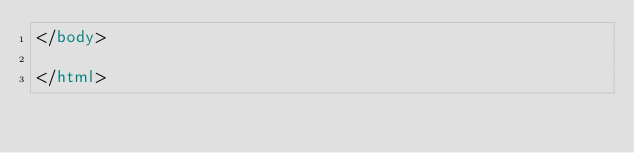<code> <loc_0><loc_0><loc_500><loc_500><_HTML_></body>

</html>
</code> 